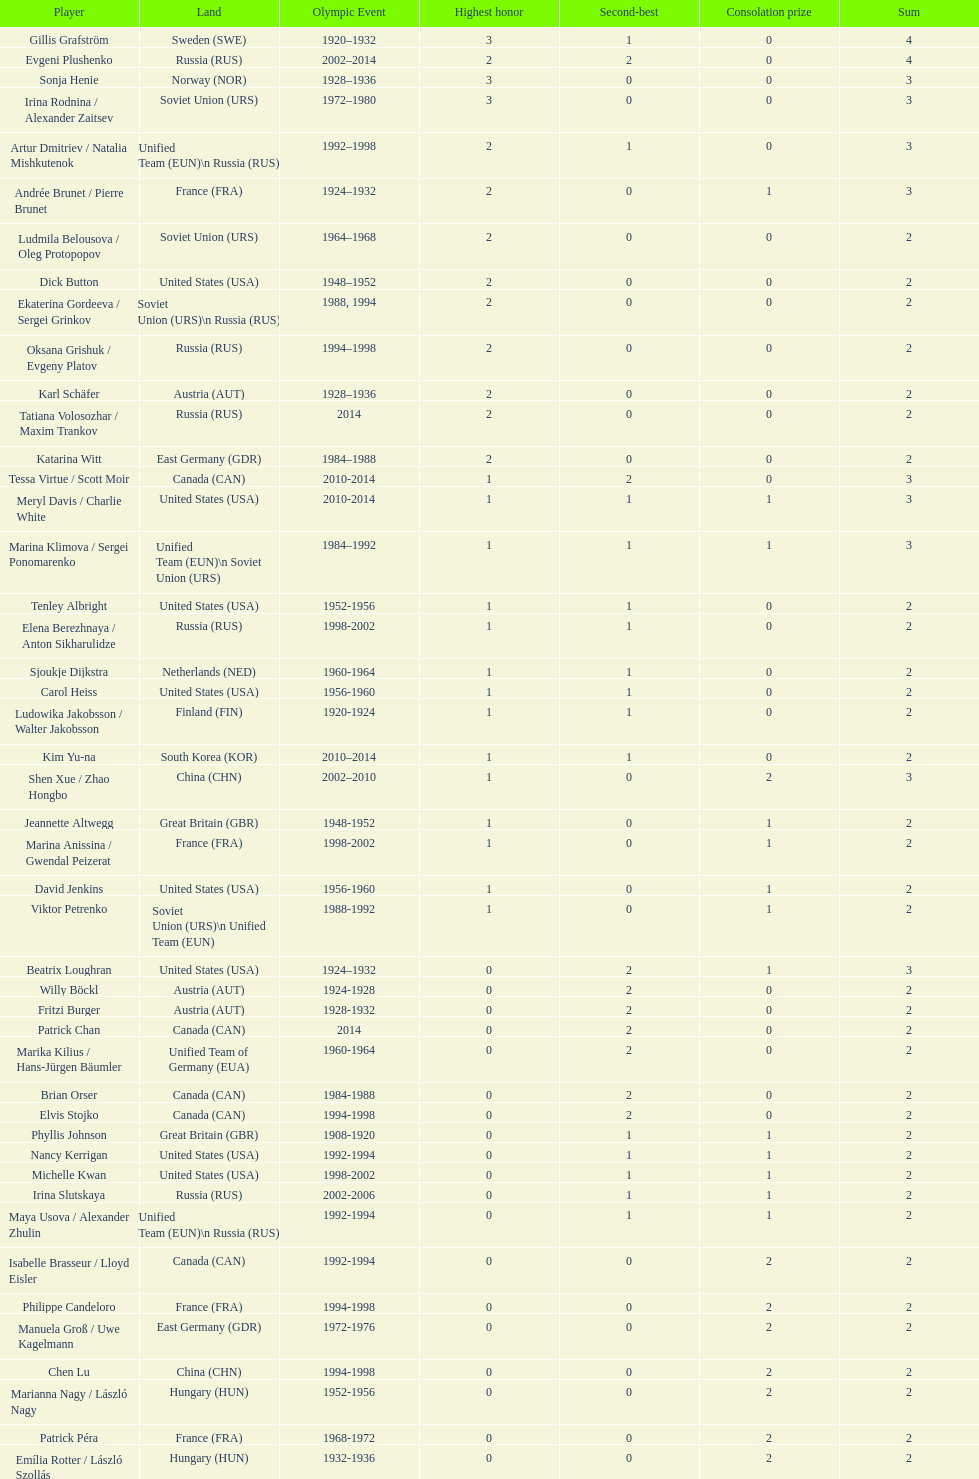How many silver medals did evgeni plushenko get? 2. 